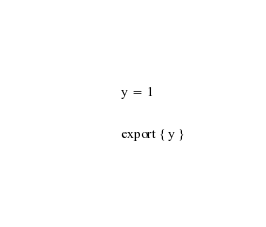Convert code to text. <code><loc_0><loc_0><loc_500><loc_500><_TypeScript_>
y = 1

export { y }
</code> 